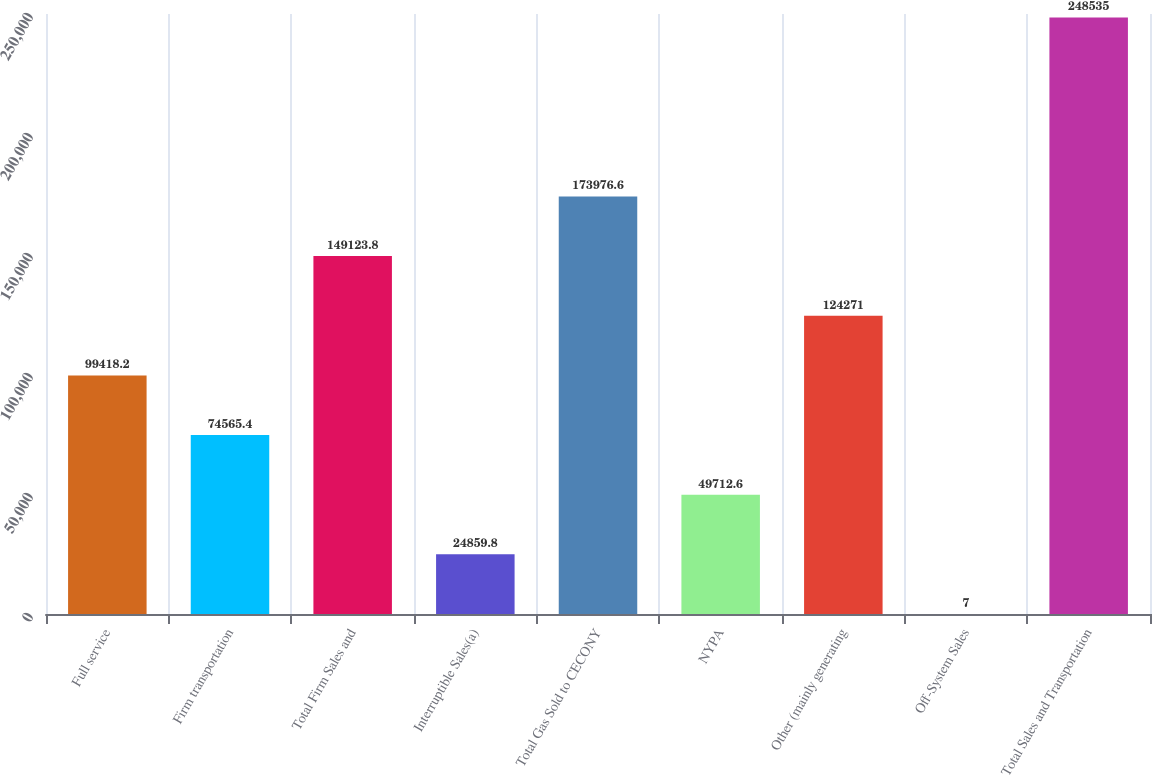<chart> <loc_0><loc_0><loc_500><loc_500><bar_chart><fcel>Full service<fcel>Firm transportation<fcel>Total Firm Sales and<fcel>Interruptible Sales(a)<fcel>Total Gas Sold to CECONY<fcel>NYPA<fcel>Other (mainly generating<fcel>Off-System Sales<fcel>Total Sales and Transportation<nl><fcel>99418.2<fcel>74565.4<fcel>149124<fcel>24859.8<fcel>173977<fcel>49712.6<fcel>124271<fcel>7<fcel>248535<nl></chart> 